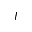Convert formula to latex. <formula><loc_0><loc_0><loc_500><loc_500>I</formula> 